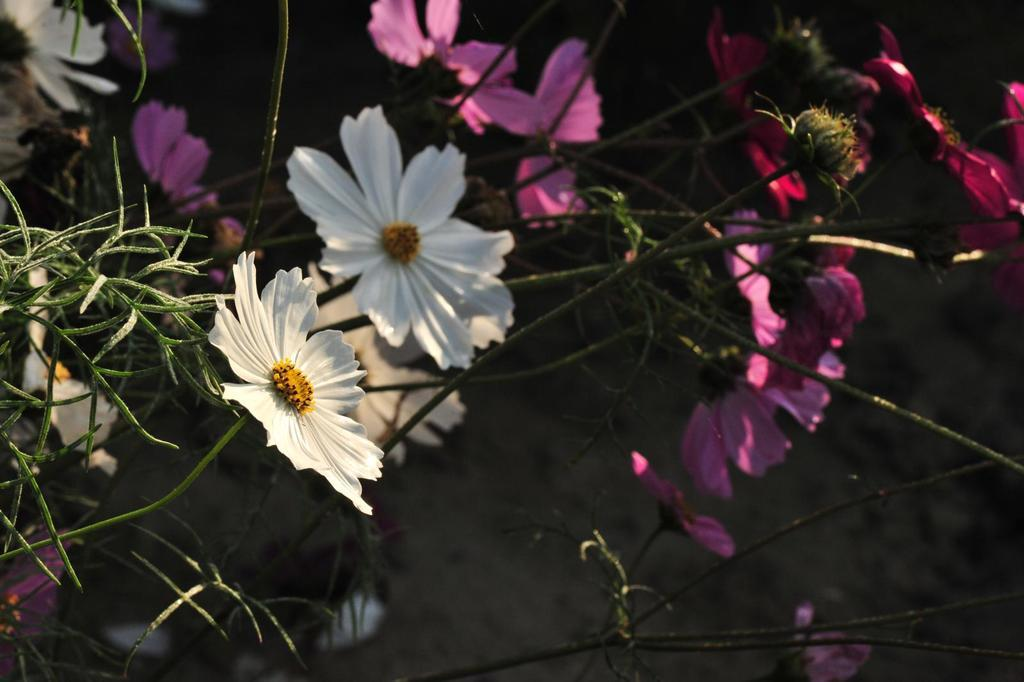What types of plants are in the image? There are flowers of different colors in the image. How are the flowers arranged in the image? The flowers are on stems. What is the color of the background in the image? The background of the image is dark. How does the heat affect the growth of the flowers in the image? There is no information about heat in the image, so it cannot be determined how it affects the flowers. Can you see a turkey in the image? No, there is no turkey present in the image. Is there a ring visible on any of the flowers in the image? No, there is no ring visible on any of the flowers in the image. 